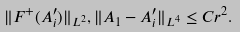Convert formula to latex. <formula><loc_0><loc_0><loc_500><loc_500>\| F ^ { + } ( A ^ { \prime } _ { i } ) \| _ { L ^ { 2 } } , \| A _ { 1 } - A ^ { \prime } _ { i } \| _ { L ^ { 4 } } \leq C r ^ { 2 } .</formula> 